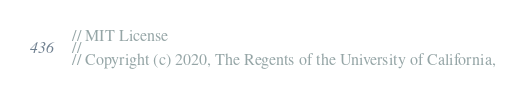Convert code to text. <code><loc_0><loc_0><loc_500><loc_500><_C++_>// MIT License
//
// Copyright (c) 2020, The Regents of the University of California,</code> 